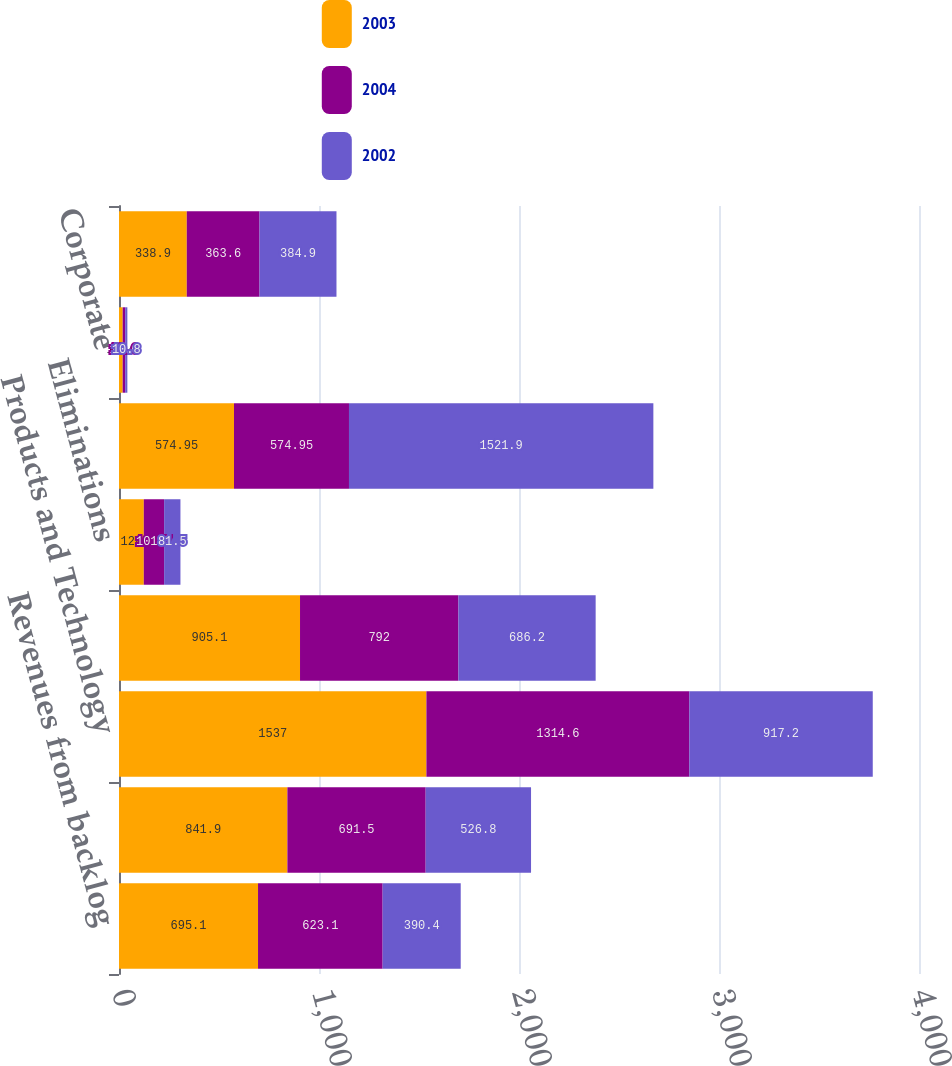Convert chart. <chart><loc_0><loc_0><loc_500><loc_500><stacked_bar_chart><ecel><fcel>Revenues from backlog<fcel>Noncapital equipment<fcel>Products and Technology<fcel>Distribution Services<fcel>Eliminations<fcel>Total<fcel>Corporate<fcel>Beginning of year<nl><fcel>2003<fcel>695.1<fcel>841.9<fcel>1537<fcel>905.1<fcel>124<fcel>574.95<fcel>18.4<fcel>338.9<nl><fcel>2004<fcel>623.1<fcel>691.5<fcel>1314.6<fcel>792<fcel>101.7<fcel>574.95<fcel>12.6<fcel>363.6<nl><fcel>2002<fcel>390.4<fcel>526.8<fcel>917.2<fcel>686.2<fcel>81.5<fcel>1521.9<fcel>10.8<fcel>384.9<nl></chart> 